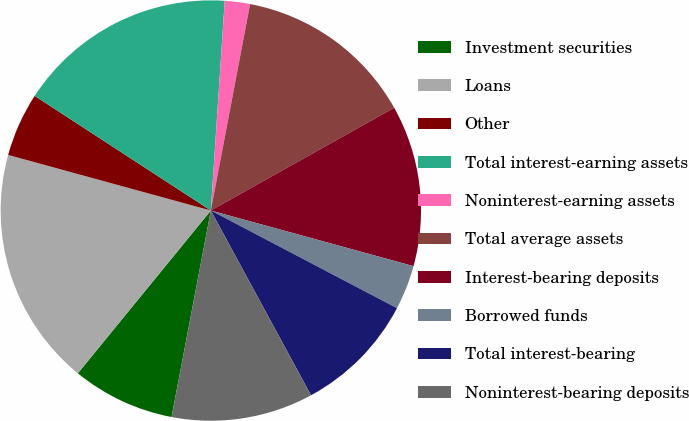<chart> <loc_0><loc_0><loc_500><loc_500><pie_chart><fcel>Investment securities<fcel>Loans<fcel>Other<fcel>Total interest-earning assets<fcel>Noninterest-earning assets<fcel>Total average assets<fcel>Interest-bearing deposits<fcel>Borrowed funds<fcel>Total interest-bearing<fcel>Noninterest-bearing deposits<nl><fcel>7.91%<fcel>18.36%<fcel>4.92%<fcel>16.87%<fcel>1.94%<fcel>13.88%<fcel>12.39%<fcel>3.43%<fcel>9.4%<fcel>10.9%<nl></chart> 